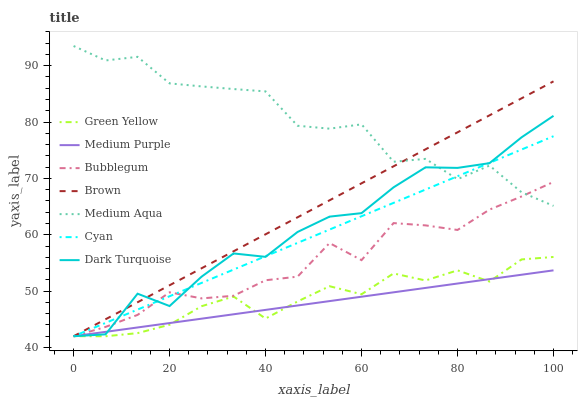Does Medium Purple have the minimum area under the curve?
Answer yes or no. Yes. Does Medium Aqua have the maximum area under the curve?
Answer yes or no. Yes. Does Dark Turquoise have the minimum area under the curve?
Answer yes or no. No. Does Dark Turquoise have the maximum area under the curve?
Answer yes or no. No. Is Medium Purple the smoothest?
Answer yes or no. Yes. Is Medium Aqua the roughest?
Answer yes or no. Yes. Is Dark Turquoise the smoothest?
Answer yes or no. No. Is Dark Turquoise the roughest?
Answer yes or no. No. Does Brown have the lowest value?
Answer yes or no. Yes. Does Medium Aqua have the lowest value?
Answer yes or no. No. Does Medium Aqua have the highest value?
Answer yes or no. Yes. Does Dark Turquoise have the highest value?
Answer yes or no. No. Is Green Yellow less than Medium Aqua?
Answer yes or no. Yes. Is Medium Aqua greater than Medium Purple?
Answer yes or no. Yes. Does Cyan intersect Medium Aqua?
Answer yes or no. Yes. Is Cyan less than Medium Aqua?
Answer yes or no. No. Is Cyan greater than Medium Aqua?
Answer yes or no. No. Does Green Yellow intersect Medium Aqua?
Answer yes or no. No. 